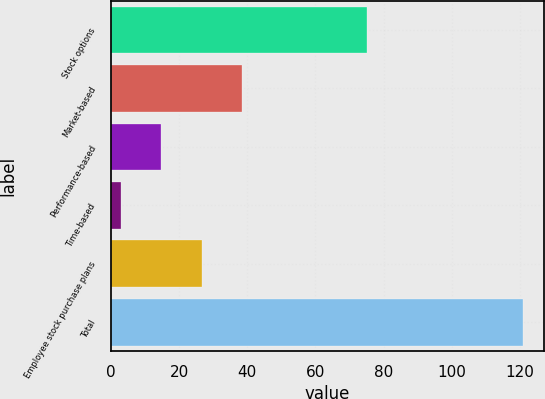Convert chart. <chart><loc_0><loc_0><loc_500><loc_500><bar_chart><fcel>Stock options<fcel>Market-based<fcel>Performance-based<fcel>Time-based<fcel>Employee stock purchase plans<fcel>Total<nl><fcel>75<fcel>38.4<fcel>14.8<fcel>3<fcel>26.6<fcel>121<nl></chart> 